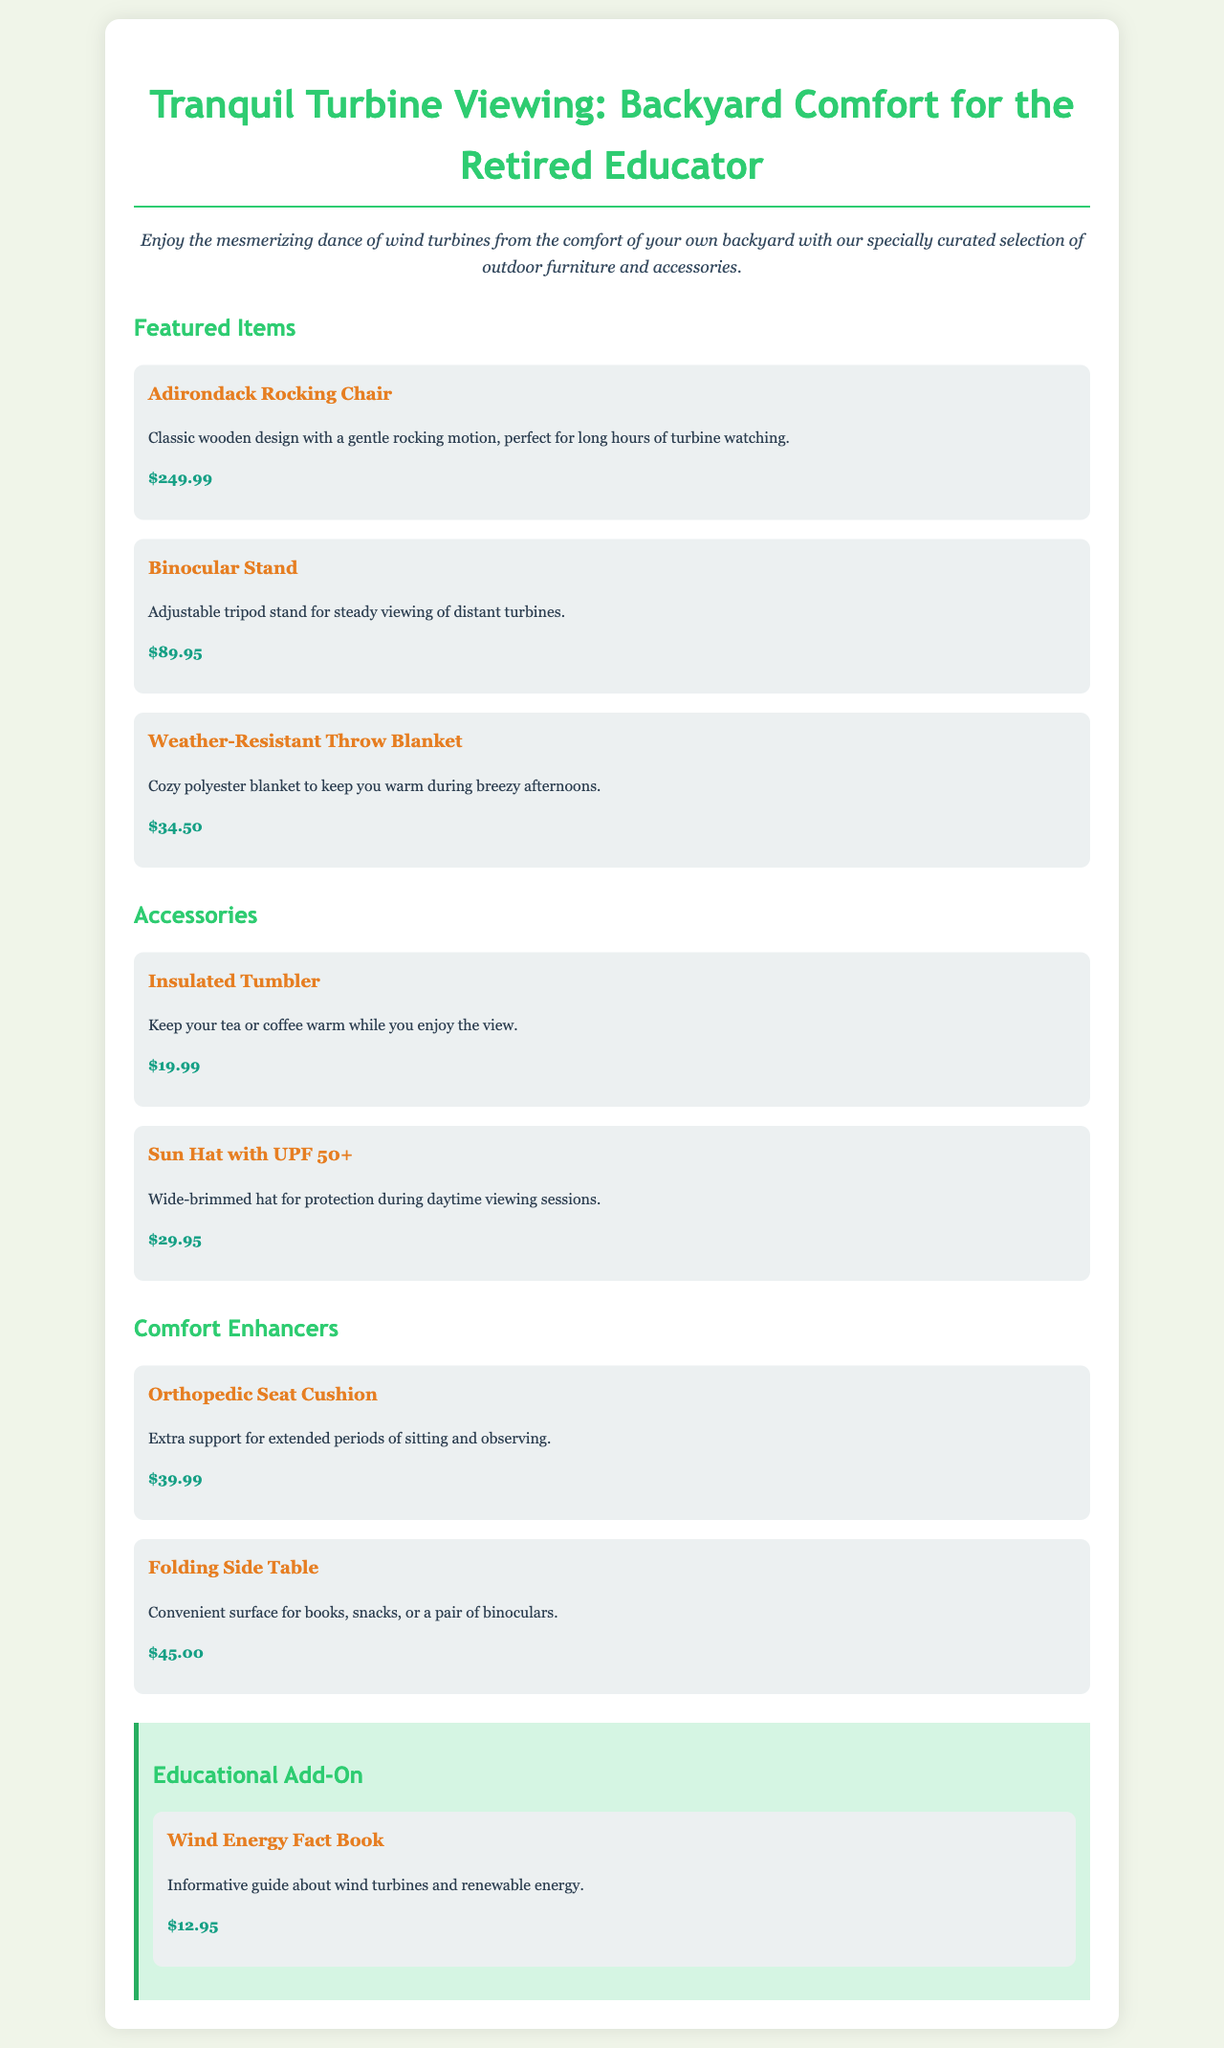What is the price of the Adirondack Rocking Chair? The price is listed directly below the item description in the document.
Answer: $249.99 What type of material is the Weather-Resistant Throw Blanket made from? The item description specifies the material of the throw blanket.
Answer: Polyester How much does the Insulated Tumbler cost? The price is listed in the accessories section of the document.
Answer: $19.99 Which item offers protection during daytime viewing? The item description indicates its purpose related to sun protection.
Answer: Sun Hat with UPF 50+ What is the function of the Folding Side Table? The description clarifies the practical use of the table for various items.
Answer: Convenient surface for books, snacks, or a pair of binoculars How much would you spend if you buy all featured items? The total cost is calculated by adding the prices of all featured items.
Answer: $374.44 What is the purpose of the Orthopedic Seat Cushion? The description explains its use for enhancing comfort during use.
Answer: Extra support for extended periods of sitting and observing What educational material is included in the catalog? The specific item related to education is mentioned under the educational add-on section.
Answer: Wind Energy Fact Book What color scheme is used for the background of the catalog? The design of the document specifies the background color.
Answer: #f0f5e9 